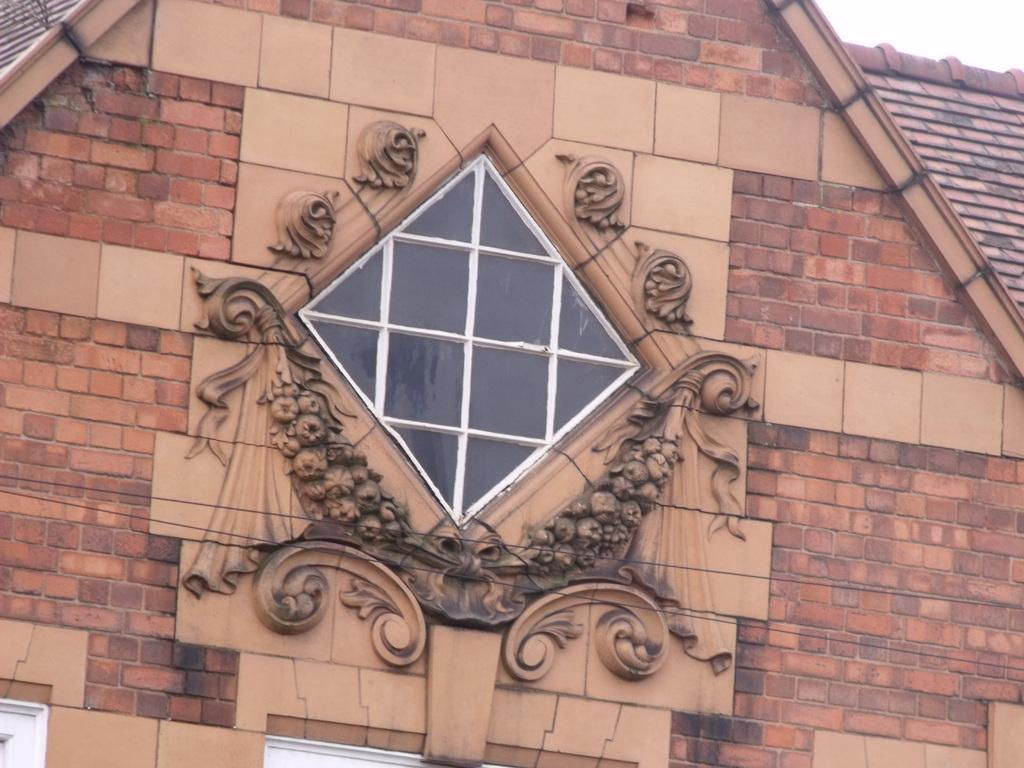What type of walls are visible in the image? There are brick walls in the image. What kind of design or pattern can be seen on the walls? There is carving in the image. What is the material of the object that appears to be transparent? There is a glass object in the image. What color are the objects located at the bottom of the image? There are white color objects at the bottom of the image. What is the hand doing in the image? There is no hand present in the image. What is the reaction of the person in the image when they see the surprise? There is no person or surprise present in the image. 